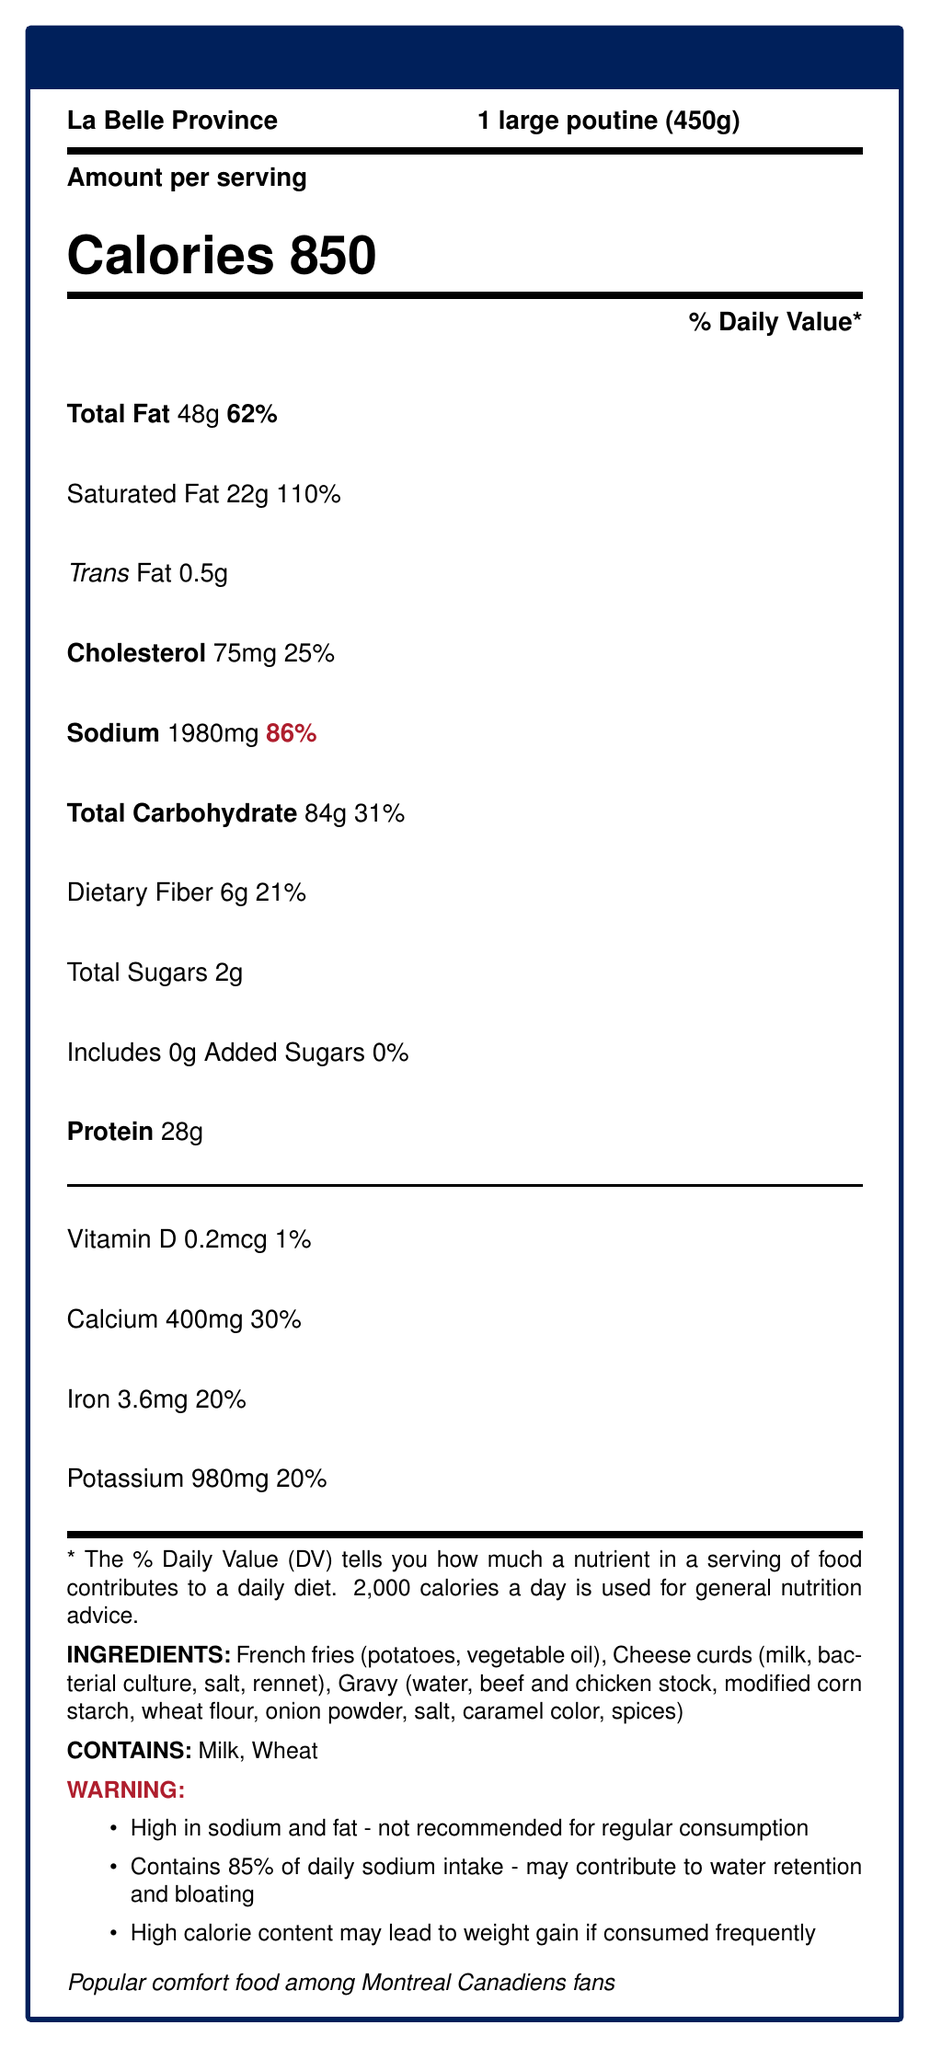what is the serving size? The serving size is listed right beneath the restaurant name, "La Belle Province."
Answer: 1 large poutine (450g) how many calories are in one serving of poutine? The calories are prominently displayed in large text just below "Amount per serving."
Answer: 850 what is the total fat content in grams? The total fat content is listed in the section with daily values.
Answer: 48g how much sodium does one serving contain? Sodium content is provided along with its daily value percentage.
Answer: 1980mg how much protein is in a serving? The protein content is listed towards the bottom of the main nutrient section.
Answer: 28g what percentage of the daily value is the saturated fat content? The percentage daily value for saturated fat is listed to the right of the amount in grams.
Answer: 110% which two ingredients are allergens in the poutine? A. Peanuts and Shellfish B. Milk and Wheat C. Soy and Egg The allergens section lists "Contains: Milk, Wheat."
Answer: B how much calcium is present in one serving? A. 200mg B. 400mg C. 600mg D. 800mg The document states that each serving contains 400mg of calcium.
Answer: B Is the amount of added sugars significant to the daily value? The added sugars are listed as 0g and 0% of the daily value.
Answer: No Is consuming this poutine frequently recommended according to the additional information? The additional info states it is high in sodium and fat and not recommended for regular consumption.
Answer: No summarize the main points of this nutrition facts label. This summary encapsulates the key nutritional aspects and health warnings provided in the document.
Answer: One large poutine serving from La Belle Province contains high levels of calories, sodium, and fat, making it a less healthy choice for frequent consumption. It serves 850 calories, 1980mg of sodium, and 48g of total fat. It is also high in saturated fats, with 110% of the daily value. The dish includes allergens like milk and wheat and offers a cautionary note on potential health risks such as weight gain and water retention. what specific bacterial culture is used in cheese curds? The document only mentions "bacterial culture" without specifying the type used in the cheese curds.
Answer: Not enough information 